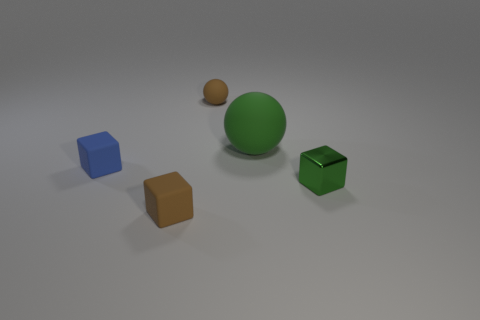Is there any other thing that is the same size as the green matte object?
Offer a very short reply. No. What is the color of the other small rubber object that is the same shape as the tiny blue rubber thing?
Ensure brevity in your answer.  Brown. Is the shape of the tiny green metal thing the same as the green rubber thing?
Ensure brevity in your answer.  No. How many yellow objects are made of the same material as the small ball?
Your answer should be compact. 0. What number of objects are either metal things or tiny objects?
Provide a short and direct response. 4. Are there any tiny metallic blocks on the right side of the brown rubber thing that is behind the large thing?
Provide a succinct answer. Yes. Is the number of small brown matte things to the right of the brown cube greater than the number of big matte balls that are left of the tiny blue thing?
Give a very brief answer. Yes. There is a block that is the same color as the large object; what is it made of?
Your answer should be very brief. Metal. How many other big things have the same color as the shiny object?
Give a very brief answer. 1. Is the color of the small rubber object in front of the shiny cube the same as the matte sphere that is behind the green rubber thing?
Keep it short and to the point. Yes. 